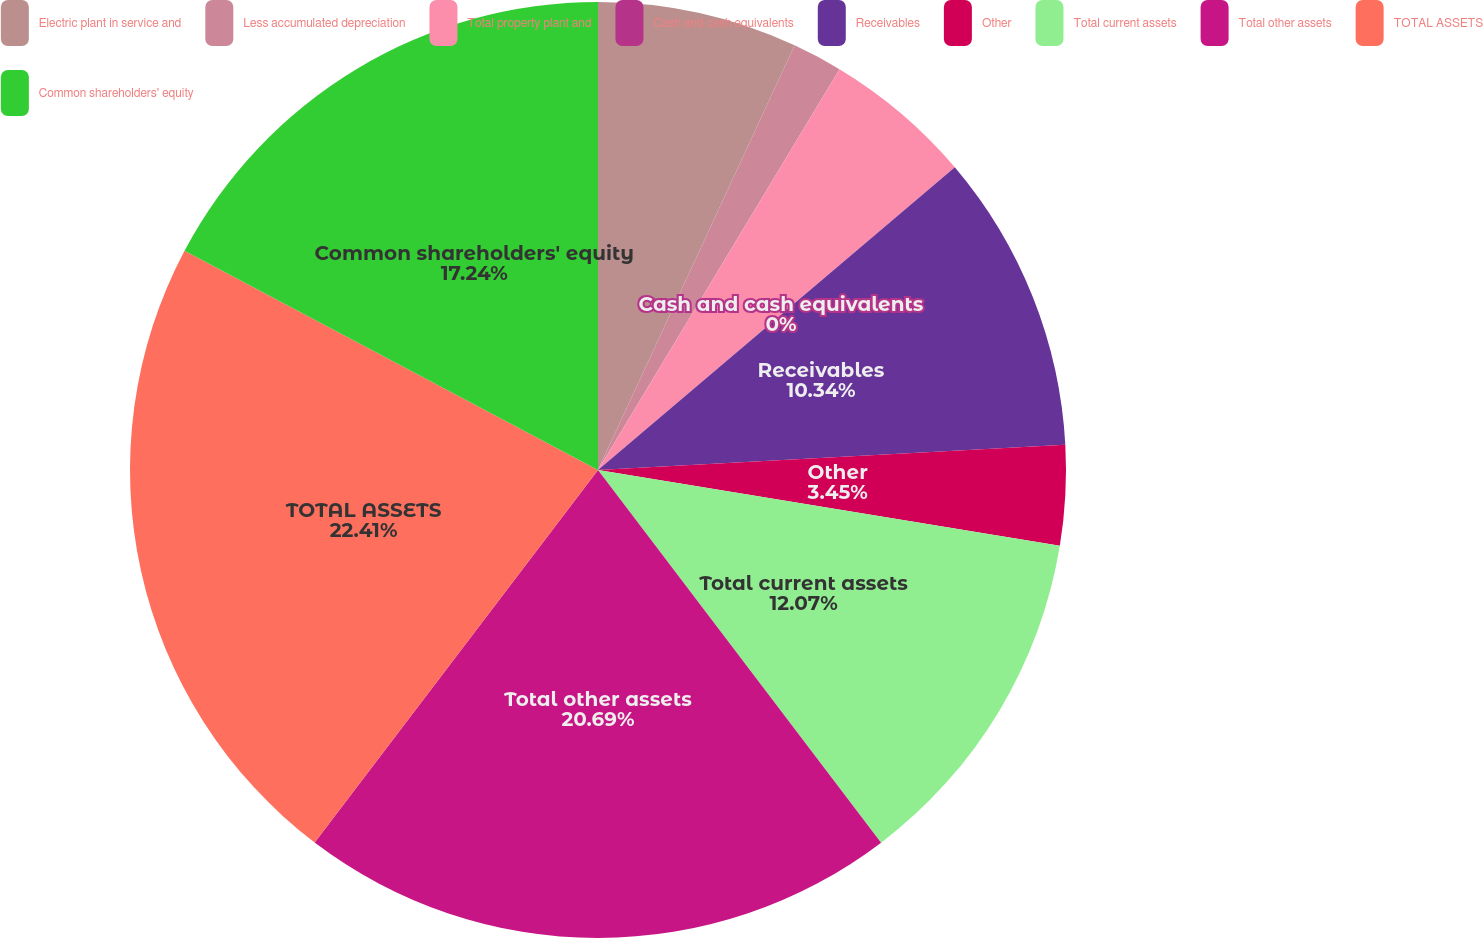<chart> <loc_0><loc_0><loc_500><loc_500><pie_chart><fcel>Electric plant in service and<fcel>Less accumulated depreciation<fcel>Total property plant and<fcel>Cash and cash equivalents<fcel>Receivables<fcel>Other<fcel>Total current assets<fcel>Total other assets<fcel>TOTAL ASSETS<fcel>Common shareholders' equity<nl><fcel>6.9%<fcel>1.73%<fcel>5.17%<fcel>0.0%<fcel>10.34%<fcel>3.45%<fcel>12.07%<fcel>20.69%<fcel>22.41%<fcel>17.24%<nl></chart> 